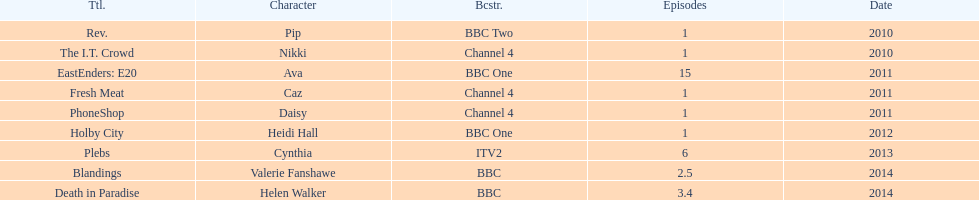How many television credits does this actress have? 9. 